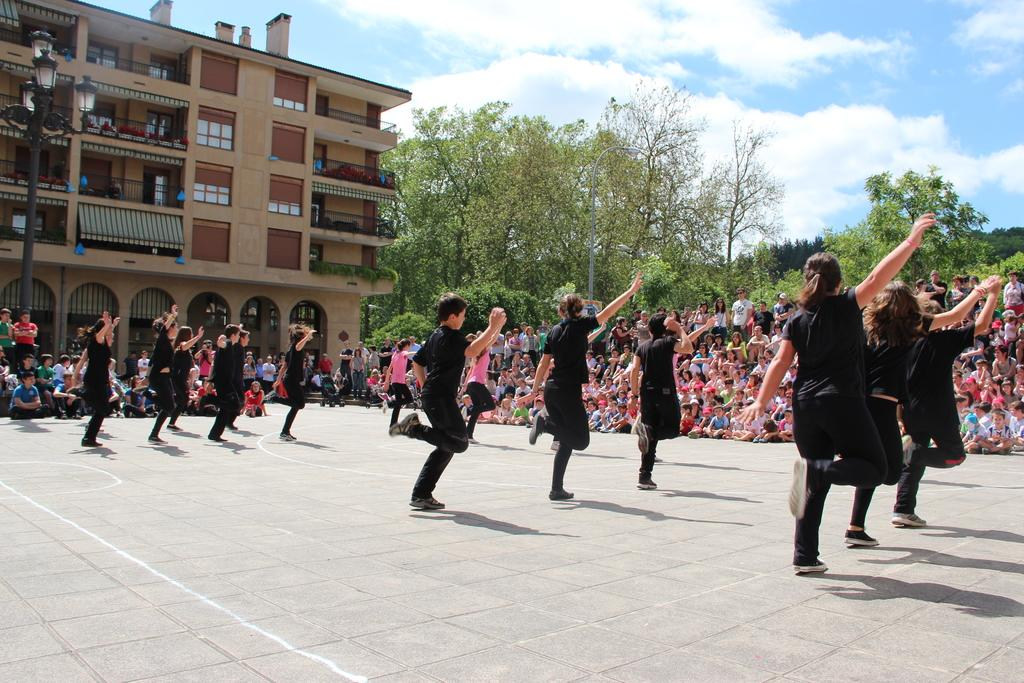What are the people in the image doing? There is a group of people dancing in the image. Can you describe the background of the image? There is a group of people, trees, a building, lights on poles, and the sky visible in the background of the image. What type of ink can be seen on the woman's dress in the image? There is no woman or ink present in the image; it features a group of people dancing. 